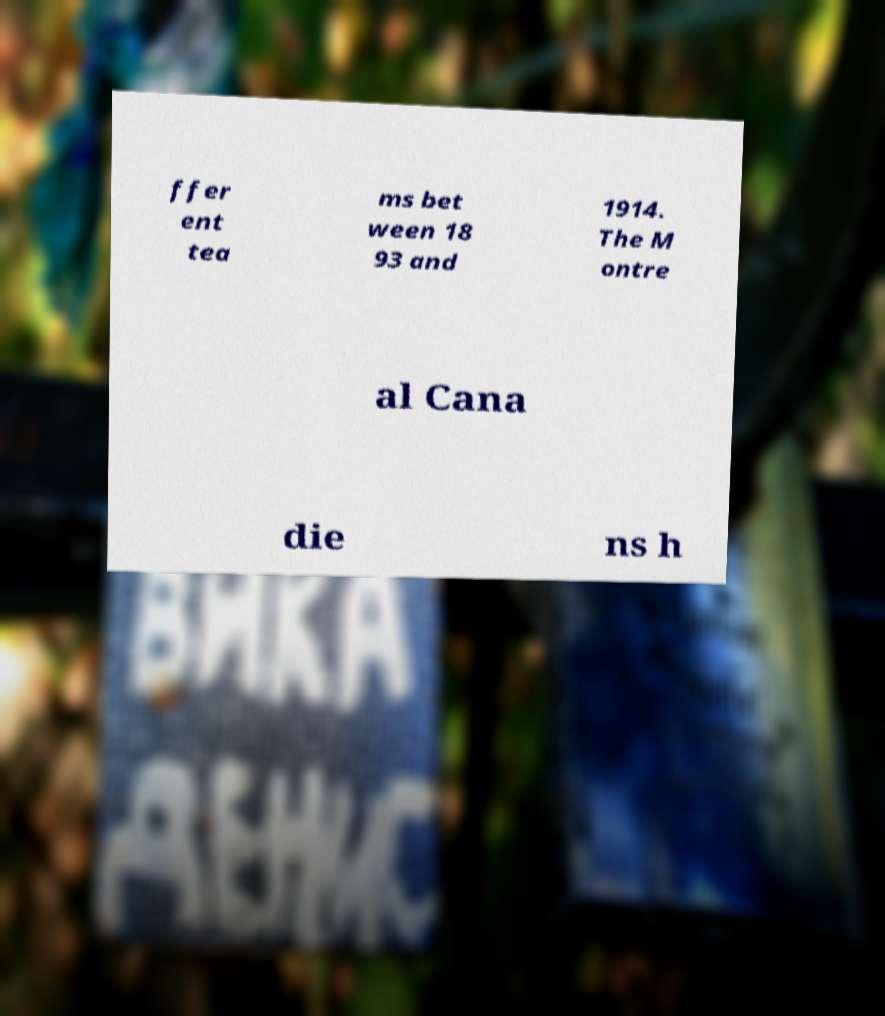Please read and relay the text visible in this image. What does it say? ffer ent tea ms bet ween 18 93 and 1914. The M ontre al Cana die ns h 